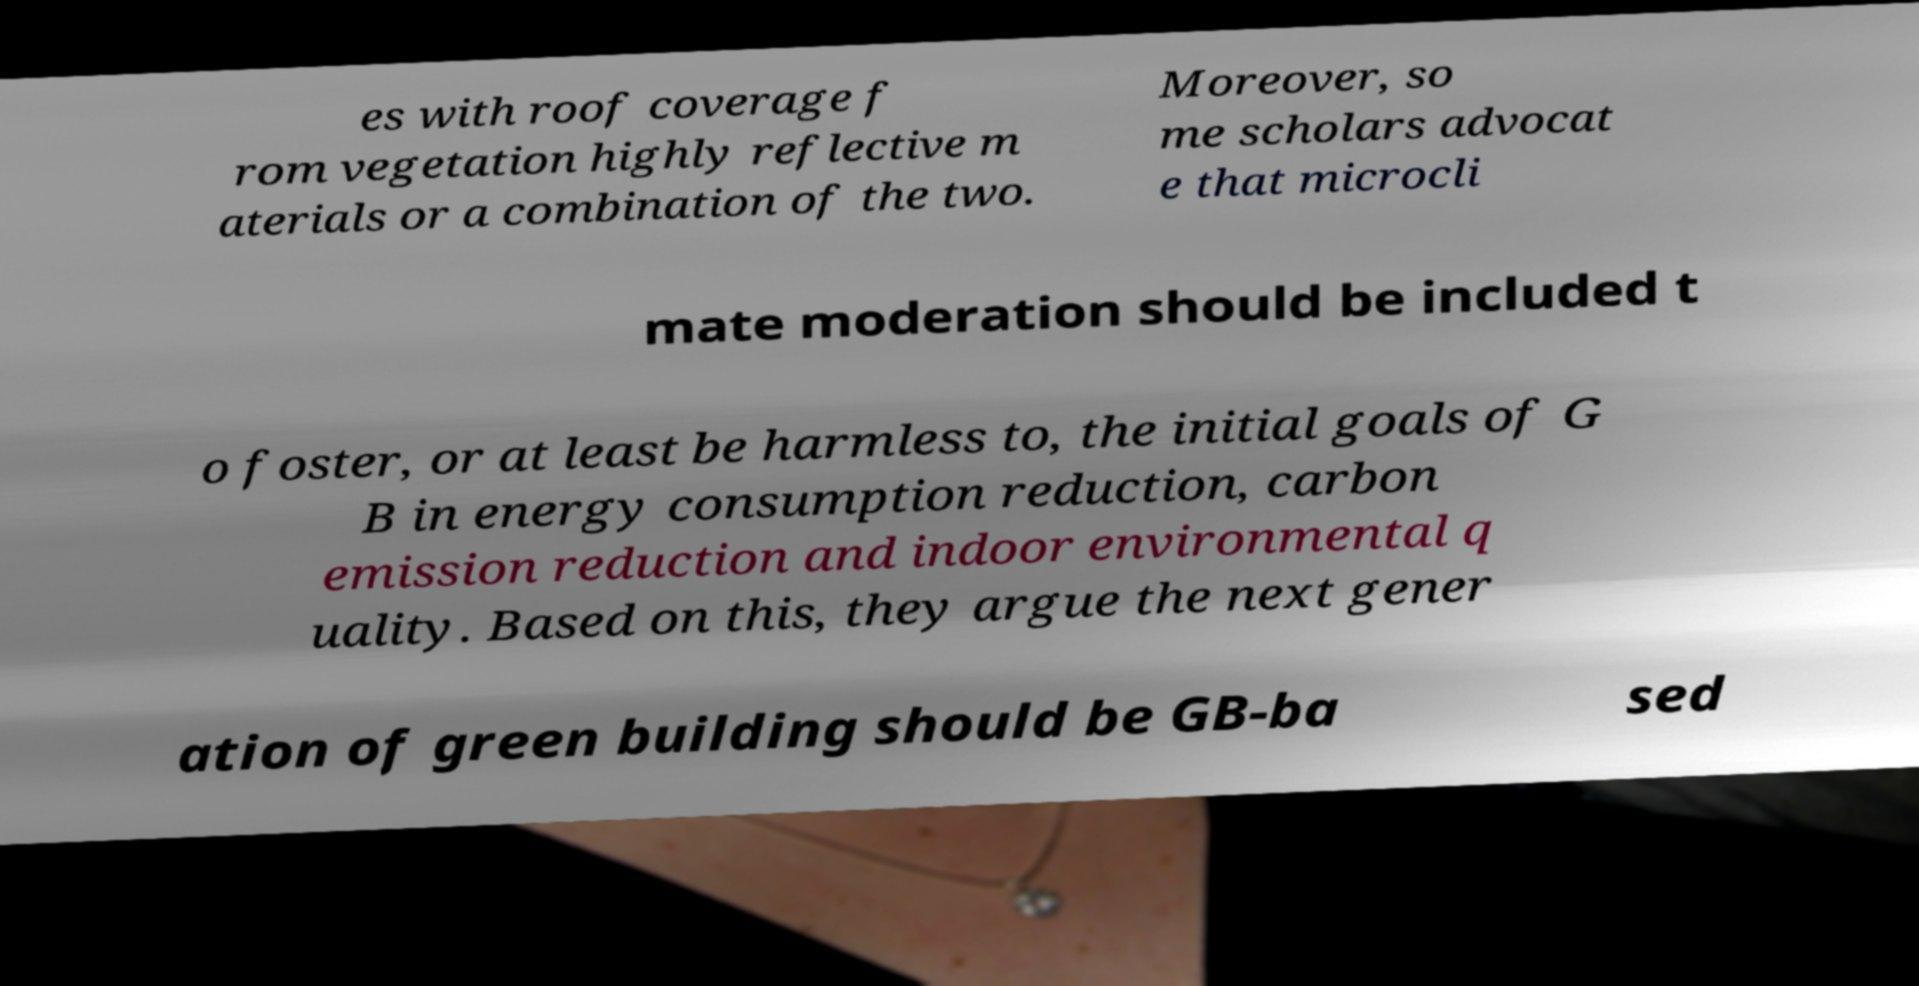What messages or text are displayed in this image? I need them in a readable, typed format. es with roof coverage f rom vegetation highly reflective m aterials or a combination of the two. Moreover, so me scholars advocat e that microcli mate moderation should be included t o foster, or at least be harmless to, the initial goals of G B in energy consumption reduction, carbon emission reduction and indoor environmental q uality. Based on this, they argue the next gener ation of green building should be GB-ba sed 